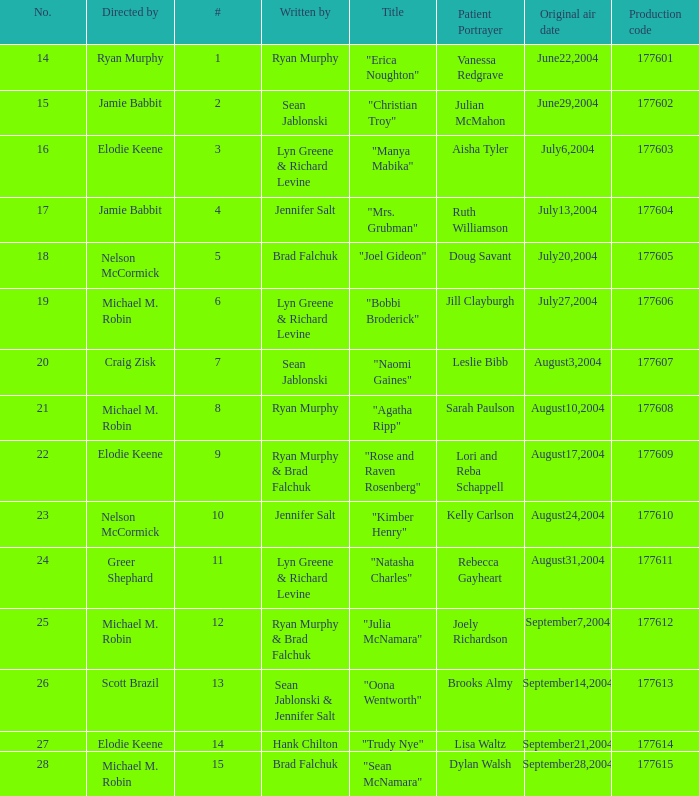How many episodes are numbered 4 in the season? 1.0. 